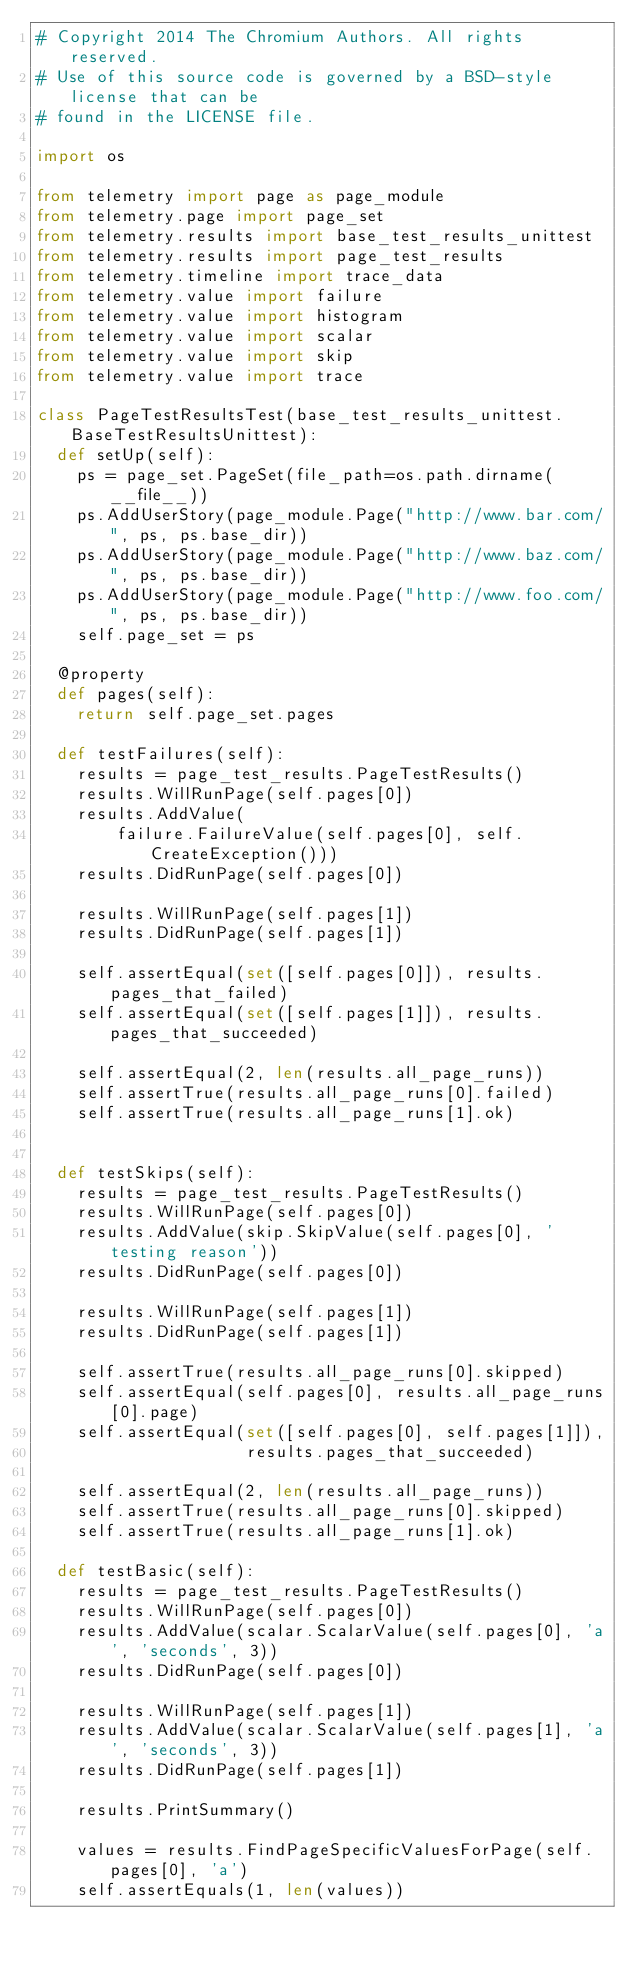Convert code to text. <code><loc_0><loc_0><loc_500><loc_500><_Python_># Copyright 2014 The Chromium Authors. All rights reserved.
# Use of this source code is governed by a BSD-style license that can be
# found in the LICENSE file.

import os

from telemetry import page as page_module
from telemetry.page import page_set
from telemetry.results import base_test_results_unittest
from telemetry.results import page_test_results
from telemetry.timeline import trace_data
from telemetry.value import failure
from telemetry.value import histogram
from telemetry.value import scalar
from telemetry.value import skip
from telemetry.value import trace

class PageTestResultsTest(base_test_results_unittest.BaseTestResultsUnittest):
  def setUp(self):
    ps = page_set.PageSet(file_path=os.path.dirname(__file__))
    ps.AddUserStory(page_module.Page("http://www.bar.com/", ps, ps.base_dir))
    ps.AddUserStory(page_module.Page("http://www.baz.com/", ps, ps.base_dir))
    ps.AddUserStory(page_module.Page("http://www.foo.com/", ps, ps.base_dir))
    self.page_set = ps

  @property
  def pages(self):
    return self.page_set.pages

  def testFailures(self):
    results = page_test_results.PageTestResults()
    results.WillRunPage(self.pages[0])
    results.AddValue(
        failure.FailureValue(self.pages[0], self.CreateException()))
    results.DidRunPage(self.pages[0])

    results.WillRunPage(self.pages[1])
    results.DidRunPage(self.pages[1])

    self.assertEqual(set([self.pages[0]]), results.pages_that_failed)
    self.assertEqual(set([self.pages[1]]), results.pages_that_succeeded)

    self.assertEqual(2, len(results.all_page_runs))
    self.assertTrue(results.all_page_runs[0].failed)
    self.assertTrue(results.all_page_runs[1].ok)


  def testSkips(self):
    results = page_test_results.PageTestResults()
    results.WillRunPage(self.pages[0])
    results.AddValue(skip.SkipValue(self.pages[0], 'testing reason'))
    results.DidRunPage(self.pages[0])

    results.WillRunPage(self.pages[1])
    results.DidRunPage(self.pages[1])

    self.assertTrue(results.all_page_runs[0].skipped)
    self.assertEqual(self.pages[0], results.all_page_runs[0].page)
    self.assertEqual(set([self.pages[0], self.pages[1]]),
                     results.pages_that_succeeded)

    self.assertEqual(2, len(results.all_page_runs))
    self.assertTrue(results.all_page_runs[0].skipped)
    self.assertTrue(results.all_page_runs[1].ok)

  def testBasic(self):
    results = page_test_results.PageTestResults()
    results.WillRunPage(self.pages[0])
    results.AddValue(scalar.ScalarValue(self.pages[0], 'a', 'seconds', 3))
    results.DidRunPage(self.pages[0])

    results.WillRunPage(self.pages[1])
    results.AddValue(scalar.ScalarValue(self.pages[1], 'a', 'seconds', 3))
    results.DidRunPage(self.pages[1])

    results.PrintSummary()

    values = results.FindPageSpecificValuesForPage(self.pages[0], 'a')
    self.assertEquals(1, len(values))</code> 